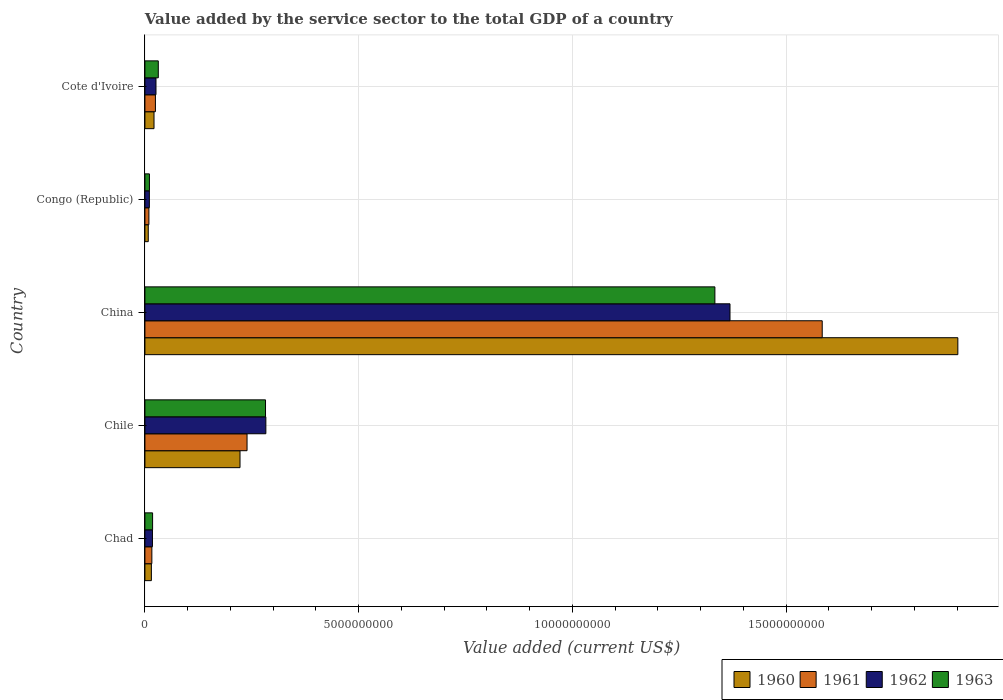How many different coloured bars are there?
Offer a very short reply. 4. What is the label of the 2nd group of bars from the top?
Your answer should be compact. Congo (Republic). In how many cases, is the number of bars for a given country not equal to the number of legend labels?
Provide a succinct answer. 0. What is the value added by the service sector to the total GDP in 1960 in Chile?
Make the answer very short. 2.22e+09. Across all countries, what is the maximum value added by the service sector to the total GDP in 1962?
Offer a very short reply. 1.37e+1. Across all countries, what is the minimum value added by the service sector to the total GDP in 1962?
Offer a terse response. 1.04e+08. In which country was the value added by the service sector to the total GDP in 1962 minimum?
Offer a terse response. Congo (Republic). What is the total value added by the service sector to the total GDP in 1962 in the graph?
Your response must be concise. 1.71e+1. What is the difference between the value added by the service sector to the total GDP in 1962 in Chad and that in China?
Keep it short and to the point. -1.35e+1. What is the difference between the value added by the service sector to the total GDP in 1961 in Chile and the value added by the service sector to the total GDP in 1962 in Congo (Republic)?
Provide a succinct answer. 2.29e+09. What is the average value added by the service sector to the total GDP in 1960 per country?
Your answer should be very brief. 4.34e+09. What is the difference between the value added by the service sector to the total GDP in 1963 and value added by the service sector to the total GDP in 1961 in Chad?
Your answer should be very brief. 1.71e+07. What is the ratio of the value added by the service sector to the total GDP in 1962 in Congo (Republic) to that in Cote d'Ivoire?
Your answer should be compact. 0.4. What is the difference between the highest and the second highest value added by the service sector to the total GDP in 1961?
Offer a terse response. 1.35e+1. What is the difference between the highest and the lowest value added by the service sector to the total GDP in 1963?
Your answer should be compact. 1.32e+1. What does the 2nd bar from the bottom in Congo (Republic) represents?
Your answer should be compact. 1961. Does the graph contain grids?
Give a very brief answer. Yes. Where does the legend appear in the graph?
Make the answer very short. Bottom right. How many legend labels are there?
Your response must be concise. 4. How are the legend labels stacked?
Offer a very short reply. Horizontal. What is the title of the graph?
Provide a short and direct response. Value added by the service sector to the total GDP of a country. What is the label or title of the X-axis?
Provide a succinct answer. Value added (current US$). What is the label or title of the Y-axis?
Give a very brief answer. Country. What is the Value added (current US$) of 1960 in Chad?
Provide a succinct answer. 1.51e+08. What is the Value added (current US$) in 1961 in Chad?
Make the answer very short. 1.62e+08. What is the Value added (current US$) of 1962 in Chad?
Ensure brevity in your answer.  1.76e+08. What is the Value added (current US$) of 1963 in Chad?
Provide a short and direct response. 1.80e+08. What is the Value added (current US$) of 1960 in Chile?
Your response must be concise. 2.22e+09. What is the Value added (current US$) in 1961 in Chile?
Provide a succinct answer. 2.39e+09. What is the Value added (current US$) of 1962 in Chile?
Give a very brief answer. 2.83e+09. What is the Value added (current US$) of 1963 in Chile?
Keep it short and to the point. 2.82e+09. What is the Value added (current US$) of 1960 in China?
Offer a terse response. 1.90e+1. What is the Value added (current US$) in 1961 in China?
Your response must be concise. 1.58e+1. What is the Value added (current US$) of 1962 in China?
Give a very brief answer. 1.37e+1. What is the Value added (current US$) of 1963 in China?
Provide a succinct answer. 1.33e+1. What is the Value added (current US$) in 1960 in Congo (Republic)?
Your answer should be compact. 7.82e+07. What is the Value added (current US$) in 1961 in Congo (Republic)?
Your answer should be very brief. 9.33e+07. What is the Value added (current US$) in 1962 in Congo (Republic)?
Make the answer very short. 1.04e+08. What is the Value added (current US$) of 1963 in Congo (Republic)?
Your answer should be very brief. 1.06e+08. What is the Value added (current US$) of 1960 in Cote d'Ivoire?
Provide a succinct answer. 2.13e+08. What is the Value added (current US$) of 1961 in Cote d'Ivoire?
Give a very brief answer. 2.46e+08. What is the Value added (current US$) of 1962 in Cote d'Ivoire?
Offer a very short reply. 2.59e+08. What is the Value added (current US$) in 1963 in Cote d'Ivoire?
Offer a very short reply. 3.13e+08. Across all countries, what is the maximum Value added (current US$) of 1960?
Keep it short and to the point. 1.90e+1. Across all countries, what is the maximum Value added (current US$) in 1961?
Give a very brief answer. 1.58e+1. Across all countries, what is the maximum Value added (current US$) of 1962?
Your answer should be compact. 1.37e+1. Across all countries, what is the maximum Value added (current US$) in 1963?
Keep it short and to the point. 1.33e+1. Across all countries, what is the minimum Value added (current US$) in 1960?
Your answer should be very brief. 7.82e+07. Across all countries, what is the minimum Value added (current US$) in 1961?
Your answer should be compact. 9.33e+07. Across all countries, what is the minimum Value added (current US$) in 1962?
Your answer should be compact. 1.04e+08. Across all countries, what is the minimum Value added (current US$) of 1963?
Ensure brevity in your answer.  1.06e+08. What is the total Value added (current US$) in 1960 in the graph?
Provide a succinct answer. 2.17e+1. What is the total Value added (current US$) of 1961 in the graph?
Your answer should be compact. 1.87e+1. What is the total Value added (current US$) in 1962 in the graph?
Your answer should be compact. 1.71e+1. What is the total Value added (current US$) in 1963 in the graph?
Offer a very short reply. 1.68e+1. What is the difference between the Value added (current US$) in 1960 in Chad and that in Chile?
Offer a terse response. -2.07e+09. What is the difference between the Value added (current US$) in 1961 in Chad and that in Chile?
Give a very brief answer. -2.23e+09. What is the difference between the Value added (current US$) in 1962 in Chad and that in Chile?
Ensure brevity in your answer.  -2.65e+09. What is the difference between the Value added (current US$) of 1963 in Chad and that in Chile?
Your response must be concise. -2.64e+09. What is the difference between the Value added (current US$) in 1960 in Chad and that in China?
Ensure brevity in your answer.  -1.89e+1. What is the difference between the Value added (current US$) in 1961 in Chad and that in China?
Offer a very short reply. -1.57e+1. What is the difference between the Value added (current US$) of 1962 in Chad and that in China?
Offer a terse response. -1.35e+1. What is the difference between the Value added (current US$) in 1963 in Chad and that in China?
Provide a short and direct response. -1.32e+1. What is the difference between the Value added (current US$) in 1960 in Chad and that in Congo (Republic)?
Offer a terse response. 7.27e+07. What is the difference between the Value added (current US$) in 1961 in Chad and that in Congo (Republic)?
Offer a terse response. 6.92e+07. What is the difference between the Value added (current US$) in 1962 in Chad and that in Congo (Republic)?
Ensure brevity in your answer.  7.25e+07. What is the difference between the Value added (current US$) in 1963 in Chad and that in Congo (Republic)?
Your response must be concise. 7.41e+07. What is the difference between the Value added (current US$) in 1960 in Chad and that in Cote d'Ivoire?
Give a very brief answer. -6.18e+07. What is the difference between the Value added (current US$) of 1961 in Chad and that in Cote d'Ivoire?
Your answer should be very brief. -8.31e+07. What is the difference between the Value added (current US$) of 1962 in Chad and that in Cote d'Ivoire?
Your response must be concise. -8.26e+07. What is the difference between the Value added (current US$) of 1963 in Chad and that in Cote d'Ivoire?
Keep it short and to the point. -1.33e+08. What is the difference between the Value added (current US$) in 1960 in Chile and that in China?
Offer a very short reply. -1.68e+1. What is the difference between the Value added (current US$) of 1961 in Chile and that in China?
Provide a succinct answer. -1.35e+1. What is the difference between the Value added (current US$) of 1962 in Chile and that in China?
Make the answer very short. -1.09e+1. What is the difference between the Value added (current US$) of 1963 in Chile and that in China?
Offer a very short reply. -1.05e+1. What is the difference between the Value added (current US$) in 1960 in Chile and that in Congo (Republic)?
Keep it short and to the point. 2.15e+09. What is the difference between the Value added (current US$) of 1961 in Chile and that in Congo (Republic)?
Your answer should be very brief. 2.30e+09. What is the difference between the Value added (current US$) in 1962 in Chile and that in Congo (Republic)?
Keep it short and to the point. 2.73e+09. What is the difference between the Value added (current US$) in 1963 in Chile and that in Congo (Republic)?
Your answer should be very brief. 2.72e+09. What is the difference between the Value added (current US$) in 1960 in Chile and that in Cote d'Ivoire?
Your answer should be very brief. 2.01e+09. What is the difference between the Value added (current US$) in 1961 in Chile and that in Cote d'Ivoire?
Your answer should be compact. 2.14e+09. What is the difference between the Value added (current US$) of 1962 in Chile and that in Cote d'Ivoire?
Keep it short and to the point. 2.57e+09. What is the difference between the Value added (current US$) of 1963 in Chile and that in Cote d'Ivoire?
Keep it short and to the point. 2.51e+09. What is the difference between the Value added (current US$) in 1960 in China and that in Congo (Republic)?
Give a very brief answer. 1.89e+1. What is the difference between the Value added (current US$) in 1961 in China and that in Congo (Republic)?
Make the answer very short. 1.57e+1. What is the difference between the Value added (current US$) in 1962 in China and that in Congo (Republic)?
Offer a terse response. 1.36e+1. What is the difference between the Value added (current US$) of 1963 in China and that in Congo (Republic)?
Offer a very short reply. 1.32e+1. What is the difference between the Value added (current US$) of 1960 in China and that in Cote d'Ivoire?
Your answer should be compact. 1.88e+1. What is the difference between the Value added (current US$) in 1961 in China and that in Cote d'Ivoire?
Your answer should be very brief. 1.56e+1. What is the difference between the Value added (current US$) of 1962 in China and that in Cote d'Ivoire?
Your answer should be compact. 1.34e+1. What is the difference between the Value added (current US$) of 1963 in China and that in Cote d'Ivoire?
Keep it short and to the point. 1.30e+1. What is the difference between the Value added (current US$) in 1960 in Congo (Republic) and that in Cote d'Ivoire?
Offer a terse response. -1.35e+08. What is the difference between the Value added (current US$) of 1961 in Congo (Republic) and that in Cote d'Ivoire?
Your answer should be compact. -1.52e+08. What is the difference between the Value added (current US$) of 1962 in Congo (Republic) and that in Cote d'Ivoire?
Give a very brief answer. -1.55e+08. What is the difference between the Value added (current US$) of 1963 in Congo (Republic) and that in Cote d'Ivoire?
Your answer should be very brief. -2.08e+08. What is the difference between the Value added (current US$) of 1960 in Chad and the Value added (current US$) of 1961 in Chile?
Offer a terse response. -2.24e+09. What is the difference between the Value added (current US$) of 1960 in Chad and the Value added (current US$) of 1962 in Chile?
Offer a terse response. -2.68e+09. What is the difference between the Value added (current US$) of 1960 in Chad and the Value added (current US$) of 1963 in Chile?
Provide a short and direct response. -2.67e+09. What is the difference between the Value added (current US$) in 1961 in Chad and the Value added (current US$) in 1962 in Chile?
Your answer should be compact. -2.67e+09. What is the difference between the Value added (current US$) in 1961 in Chad and the Value added (current US$) in 1963 in Chile?
Offer a very short reply. -2.66e+09. What is the difference between the Value added (current US$) in 1962 in Chad and the Value added (current US$) in 1963 in Chile?
Keep it short and to the point. -2.64e+09. What is the difference between the Value added (current US$) of 1960 in Chad and the Value added (current US$) of 1961 in China?
Provide a short and direct response. -1.57e+1. What is the difference between the Value added (current US$) of 1960 in Chad and the Value added (current US$) of 1962 in China?
Offer a terse response. -1.35e+1. What is the difference between the Value added (current US$) in 1960 in Chad and the Value added (current US$) in 1963 in China?
Provide a short and direct response. -1.32e+1. What is the difference between the Value added (current US$) in 1961 in Chad and the Value added (current US$) in 1962 in China?
Ensure brevity in your answer.  -1.35e+1. What is the difference between the Value added (current US$) in 1961 in Chad and the Value added (current US$) in 1963 in China?
Your answer should be compact. -1.32e+1. What is the difference between the Value added (current US$) in 1962 in Chad and the Value added (current US$) in 1963 in China?
Provide a short and direct response. -1.32e+1. What is the difference between the Value added (current US$) in 1960 in Chad and the Value added (current US$) in 1961 in Congo (Republic)?
Your answer should be very brief. 5.77e+07. What is the difference between the Value added (current US$) in 1960 in Chad and the Value added (current US$) in 1962 in Congo (Republic)?
Offer a terse response. 4.72e+07. What is the difference between the Value added (current US$) in 1960 in Chad and the Value added (current US$) in 1963 in Congo (Republic)?
Your response must be concise. 4.54e+07. What is the difference between the Value added (current US$) in 1961 in Chad and the Value added (current US$) in 1962 in Congo (Republic)?
Give a very brief answer. 5.87e+07. What is the difference between the Value added (current US$) of 1961 in Chad and the Value added (current US$) of 1963 in Congo (Republic)?
Your response must be concise. 5.69e+07. What is the difference between the Value added (current US$) of 1962 in Chad and the Value added (current US$) of 1963 in Congo (Republic)?
Offer a very short reply. 7.08e+07. What is the difference between the Value added (current US$) of 1960 in Chad and the Value added (current US$) of 1961 in Cote d'Ivoire?
Keep it short and to the point. -9.46e+07. What is the difference between the Value added (current US$) of 1960 in Chad and the Value added (current US$) of 1962 in Cote d'Ivoire?
Keep it short and to the point. -1.08e+08. What is the difference between the Value added (current US$) of 1960 in Chad and the Value added (current US$) of 1963 in Cote d'Ivoire?
Provide a succinct answer. -1.62e+08. What is the difference between the Value added (current US$) in 1961 in Chad and the Value added (current US$) in 1962 in Cote d'Ivoire?
Offer a terse response. -9.64e+07. What is the difference between the Value added (current US$) of 1961 in Chad and the Value added (current US$) of 1963 in Cote d'Ivoire?
Ensure brevity in your answer.  -1.51e+08. What is the difference between the Value added (current US$) of 1962 in Chad and the Value added (current US$) of 1963 in Cote d'Ivoire?
Your answer should be compact. -1.37e+08. What is the difference between the Value added (current US$) of 1960 in Chile and the Value added (current US$) of 1961 in China?
Make the answer very short. -1.36e+1. What is the difference between the Value added (current US$) in 1960 in Chile and the Value added (current US$) in 1962 in China?
Offer a very short reply. -1.15e+1. What is the difference between the Value added (current US$) of 1960 in Chile and the Value added (current US$) of 1963 in China?
Your response must be concise. -1.11e+1. What is the difference between the Value added (current US$) in 1961 in Chile and the Value added (current US$) in 1962 in China?
Your response must be concise. -1.13e+1. What is the difference between the Value added (current US$) in 1961 in Chile and the Value added (current US$) in 1963 in China?
Offer a very short reply. -1.09e+1. What is the difference between the Value added (current US$) in 1962 in Chile and the Value added (current US$) in 1963 in China?
Offer a very short reply. -1.05e+1. What is the difference between the Value added (current US$) in 1960 in Chile and the Value added (current US$) in 1961 in Congo (Republic)?
Your answer should be compact. 2.13e+09. What is the difference between the Value added (current US$) in 1960 in Chile and the Value added (current US$) in 1962 in Congo (Republic)?
Offer a terse response. 2.12e+09. What is the difference between the Value added (current US$) of 1960 in Chile and the Value added (current US$) of 1963 in Congo (Republic)?
Ensure brevity in your answer.  2.12e+09. What is the difference between the Value added (current US$) in 1961 in Chile and the Value added (current US$) in 1962 in Congo (Republic)?
Offer a very short reply. 2.29e+09. What is the difference between the Value added (current US$) of 1961 in Chile and the Value added (current US$) of 1963 in Congo (Republic)?
Your answer should be very brief. 2.28e+09. What is the difference between the Value added (current US$) in 1962 in Chile and the Value added (current US$) in 1963 in Congo (Republic)?
Your response must be concise. 2.72e+09. What is the difference between the Value added (current US$) of 1960 in Chile and the Value added (current US$) of 1961 in Cote d'Ivoire?
Keep it short and to the point. 1.98e+09. What is the difference between the Value added (current US$) of 1960 in Chile and the Value added (current US$) of 1962 in Cote d'Ivoire?
Give a very brief answer. 1.97e+09. What is the difference between the Value added (current US$) of 1960 in Chile and the Value added (current US$) of 1963 in Cote d'Ivoire?
Offer a very short reply. 1.91e+09. What is the difference between the Value added (current US$) in 1961 in Chile and the Value added (current US$) in 1962 in Cote d'Ivoire?
Your answer should be very brief. 2.13e+09. What is the difference between the Value added (current US$) of 1961 in Chile and the Value added (current US$) of 1963 in Cote d'Ivoire?
Provide a succinct answer. 2.08e+09. What is the difference between the Value added (current US$) of 1962 in Chile and the Value added (current US$) of 1963 in Cote d'Ivoire?
Offer a very short reply. 2.52e+09. What is the difference between the Value added (current US$) of 1960 in China and the Value added (current US$) of 1961 in Congo (Republic)?
Provide a succinct answer. 1.89e+1. What is the difference between the Value added (current US$) of 1960 in China and the Value added (current US$) of 1962 in Congo (Republic)?
Offer a terse response. 1.89e+1. What is the difference between the Value added (current US$) in 1960 in China and the Value added (current US$) in 1963 in Congo (Republic)?
Provide a short and direct response. 1.89e+1. What is the difference between the Value added (current US$) in 1961 in China and the Value added (current US$) in 1962 in Congo (Republic)?
Offer a terse response. 1.57e+1. What is the difference between the Value added (current US$) of 1961 in China and the Value added (current US$) of 1963 in Congo (Republic)?
Provide a succinct answer. 1.57e+1. What is the difference between the Value added (current US$) of 1962 in China and the Value added (current US$) of 1963 in Congo (Republic)?
Provide a succinct answer. 1.36e+1. What is the difference between the Value added (current US$) in 1960 in China and the Value added (current US$) in 1961 in Cote d'Ivoire?
Offer a terse response. 1.88e+1. What is the difference between the Value added (current US$) of 1960 in China and the Value added (current US$) of 1962 in Cote d'Ivoire?
Your answer should be compact. 1.88e+1. What is the difference between the Value added (current US$) in 1960 in China and the Value added (current US$) in 1963 in Cote d'Ivoire?
Offer a terse response. 1.87e+1. What is the difference between the Value added (current US$) of 1961 in China and the Value added (current US$) of 1962 in Cote d'Ivoire?
Offer a terse response. 1.56e+1. What is the difference between the Value added (current US$) in 1961 in China and the Value added (current US$) in 1963 in Cote d'Ivoire?
Your answer should be compact. 1.55e+1. What is the difference between the Value added (current US$) of 1962 in China and the Value added (current US$) of 1963 in Cote d'Ivoire?
Offer a very short reply. 1.34e+1. What is the difference between the Value added (current US$) in 1960 in Congo (Republic) and the Value added (current US$) in 1961 in Cote d'Ivoire?
Keep it short and to the point. -1.67e+08. What is the difference between the Value added (current US$) of 1960 in Congo (Republic) and the Value added (current US$) of 1962 in Cote d'Ivoire?
Provide a short and direct response. -1.81e+08. What is the difference between the Value added (current US$) in 1960 in Congo (Republic) and the Value added (current US$) in 1963 in Cote d'Ivoire?
Keep it short and to the point. -2.35e+08. What is the difference between the Value added (current US$) of 1961 in Congo (Republic) and the Value added (current US$) of 1962 in Cote d'Ivoire?
Your answer should be compact. -1.66e+08. What is the difference between the Value added (current US$) of 1961 in Congo (Republic) and the Value added (current US$) of 1963 in Cote d'Ivoire?
Your answer should be compact. -2.20e+08. What is the difference between the Value added (current US$) in 1962 in Congo (Republic) and the Value added (current US$) in 1963 in Cote d'Ivoire?
Keep it short and to the point. -2.09e+08. What is the average Value added (current US$) in 1960 per country?
Provide a succinct answer. 4.34e+09. What is the average Value added (current US$) in 1961 per country?
Provide a short and direct response. 3.75e+09. What is the average Value added (current US$) of 1962 per country?
Ensure brevity in your answer.  3.41e+09. What is the average Value added (current US$) in 1963 per country?
Give a very brief answer. 3.35e+09. What is the difference between the Value added (current US$) in 1960 and Value added (current US$) in 1961 in Chad?
Provide a short and direct response. -1.15e+07. What is the difference between the Value added (current US$) of 1960 and Value added (current US$) of 1962 in Chad?
Your answer should be compact. -2.53e+07. What is the difference between the Value added (current US$) in 1960 and Value added (current US$) in 1963 in Chad?
Offer a very short reply. -2.87e+07. What is the difference between the Value added (current US$) in 1961 and Value added (current US$) in 1962 in Chad?
Ensure brevity in your answer.  -1.38e+07. What is the difference between the Value added (current US$) of 1961 and Value added (current US$) of 1963 in Chad?
Your response must be concise. -1.71e+07. What is the difference between the Value added (current US$) of 1962 and Value added (current US$) of 1963 in Chad?
Offer a very short reply. -3.34e+06. What is the difference between the Value added (current US$) of 1960 and Value added (current US$) of 1961 in Chile?
Give a very brief answer. -1.64e+08. What is the difference between the Value added (current US$) in 1960 and Value added (current US$) in 1962 in Chile?
Your response must be concise. -6.04e+08. What is the difference between the Value added (current US$) of 1960 and Value added (current US$) of 1963 in Chile?
Your answer should be compact. -5.96e+08. What is the difference between the Value added (current US$) of 1961 and Value added (current US$) of 1962 in Chile?
Offer a terse response. -4.40e+08. What is the difference between the Value added (current US$) of 1961 and Value added (current US$) of 1963 in Chile?
Offer a very short reply. -4.32e+08. What is the difference between the Value added (current US$) of 1962 and Value added (current US$) of 1963 in Chile?
Your answer should be very brief. 8.01e+06. What is the difference between the Value added (current US$) in 1960 and Value added (current US$) in 1961 in China?
Provide a short and direct response. 3.17e+09. What is the difference between the Value added (current US$) of 1960 and Value added (current US$) of 1962 in China?
Provide a short and direct response. 5.33e+09. What is the difference between the Value added (current US$) in 1960 and Value added (current US$) in 1963 in China?
Offer a terse response. 5.68e+09. What is the difference between the Value added (current US$) in 1961 and Value added (current US$) in 1962 in China?
Your answer should be compact. 2.16e+09. What is the difference between the Value added (current US$) of 1961 and Value added (current US$) of 1963 in China?
Provide a succinct answer. 2.51e+09. What is the difference between the Value added (current US$) in 1962 and Value added (current US$) in 1963 in China?
Offer a terse response. 3.53e+08. What is the difference between the Value added (current US$) of 1960 and Value added (current US$) of 1961 in Congo (Republic)?
Make the answer very short. -1.51e+07. What is the difference between the Value added (current US$) in 1960 and Value added (current US$) in 1962 in Congo (Republic)?
Your answer should be very brief. -2.55e+07. What is the difference between the Value added (current US$) of 1960 and Value added (current US$) of 1963 in Congo (Republic)?
Provide a short and direct response. -2.73e+07. What is the difference between the Value added (current US$) of 1961 and Value added (current US$) of 1962 in Congo (Republic)?
Provide a short and direct response. -1.05e+07. What is the difference between the Value added (current US$) of 1961 and Value added (current US$) of 1963 in Congo (Republic)?
Give a very brief answer. -1.23e+07. What is the difference between the Value added (current US$) in 1962 and Value added (current US$) in 1963 in Congo (Republic)?
Provide a short and direct response. -1.79e+06. What is the difference between the Value added (current US$) in 1960 and Value added (current US$) in 1961 in Cote d'Ivoire?
Keep it short and to the point. -3.28e+07. What is the difference between the Value added (current US$) of 1960 and Value added (current US$) of 1962 in Cote d'Ivoire?
Provide a short and direct response. -4.61e+07. What is the difference between the Value added (current US$) in 1960 and Value added (current US$) in 1963 in Cote d'Ivoire?
Offer a very short reply. -1.00e+08. What is the difference between the Value added (current US$) of 1961 and Value added (current US$) of 1962 in Cote d'Ivoire?
Make the answer very short. -1.33e+07. What is the difference between the Value added (current US$) in 1961 and Value added (current US$) in 1963 in Cote d'Ivoire?
Keep it short and to the point. -6.75e+07. What is the difference between the Value added (current US$) in 1962 and Value added (current US$) in 1963 in Cote d'Ivoire?
Keep it short and to the point. -5.42e+07. What is the ratio of the Value added (current US$) in 1960 in Chad to that in Chile?
Your answer should be very brief. 0.07. What is the ratio of the Value added (current US$) in 1961 in Chad to that in Chile?
Offer a terse response. 0.07. What is the ratio of the Value added (current US$) in 1962 in Chad to that in Chile?
Provide a short and direct response. 0.06. What is the ratio of the Value added (current US$) in 1963 in Chad to that in Chile?
Your response must be concise. 0.06. What is the ratio of the Value added (current US$) of 1960 in Chad to that in China?
Offer a terse response. 0.01. What is the ratio of the Value added (current US$) in 1961 in Chad to that in China?
Offer a very short reply. 0.01. What is the ratio of the Value added (current US$) of 1962 in Chad to that in China?
Your answer should be very brief. 0.01. What is the ratio of the Value added (current US$) of 1963 in Chad to that in China?
Your response must be concise. 0.01. What is the ratio of the Value added (current US$) in 1960 in Chad to that in Congo (Republic)?
Your answer should be very brief. 1.93. What is the ratio of the Value added (current US$) in 1961 in Chad to that in Congo (Republic)?
Provide a succinct answer. 1.74. What is the ratio of the Value added (current US$) in 1962 in Chad to that in Congo (Republic)?
Provide a succinct answer. 1.7. What is the ratio of the Value added (current US$) of 1963 in Chad to that in Congo (Republic)?
Keep it short and to the point. 1.7. What is the ratio of the Value added (current US$) in 1960 in Chad to that in Cote d'Ivoire?
Provide a succinct answer. 0.71. What is the ratio of the Value added (current US$) in 1961 in Chad to that in Cote d'Ivoire?
Provide a short and direct response. 0.66. What is the ratio of the Value added (current US$) of 1962 in Chad to that in Cote d'Ivoire?
Keep it short and to the point. 0.68. What is the ratio of the Value added (current US$) in 1963 in Chad to that in Cote d'Ivoire?
Give a very brief answer. 0.57. What is the ratio of the Value added (current US$) in 1960 in Chile to that in China?
Ensure brevity in your answer.  0.12. What is the ratio of the Value added (current US$) of 1961 in Chile to that in China?
Offer a terse response. 0.15. What is the ratio of the Value added (current US$) of 1962 in Chile to that in China?
Ensure brevity in your answer.  0.21. What is the ratio of the Value added (current US$) of 1963 in Chile to that in China?
Offer a terse response. 0.21. What is the ratio of the Value added (current US$) in 1960 in Chile to that in Congo (Republic)?
Offer a very short reply. 28.44. What is the ratio of the Value added (current US$) of 1961 in Chile to that in Congo (Republic)?
Provide a short and direct response. 25.61. What is the ratio of the Value added (current US$) in 1962 in Chile to that in Congo (Republic)?
Provide a succinct answer. 27.27. What is the ratio of the Value added (current US$) in 1963 in Chile to that in Congo (Republic)?
Your response must be concise. 26.73. What is the ratio of the Value added (current US$) in 1960 in Chile to that in Cote d'Ivoire?
Offer a terse response. 10.45. What is the ratio of the Value added (current US$) in 1961 in Chile to that in Cote d'Ivoire?
Your response must be concise. 9.73. What is the ratio of the Value added (current US$) of 1962 in Chile to that in Cote d'Ivoire?
Offer a terse response. 10.93. What is the ratio of the Value added (current US$) in 1963 in Chile to that in Cote d'Ivoire?
Provide a succinct answer. 9.01. What is the ratio of the Value added (current US$) in 1960 in China to that in Congo (Republic)?
Provide a succinct answer. 243.12. What is the ratio of the Value added (current US$) of 1961 in China to that in Congo (Republic)?
Offer a very short reply. 169.84. What is the ratio of the Value added (current US$) of 1962 in China to that in Congo (Republic)?
Provide a short and direct response. 131.91. What is the ratio of the Value added (current US$) of 1963 in China to that in Congo (Republic)?
Provide a succinct answer. 126.33. What is the ratio of the Value added (current US$) in 1960 in China to that in Cote d'Ivoire?
Make the answer very short. 89.37. What is the ratio of the Value added (current US$) of 1961 in China to that in Cote d'Ivoire?
Your answer should be very brief. 64.52. What is the ratio of the Value added (current US$) in 1962 in China to that in Cote d'Ivoire?
Offer a very short reply. 52.87. What is the ratio of the Value added (current US$) in 1963 in China to that in Cote d'Ivoire?
Provide a succinct answer. 42.59. What is the ratio of the Value added (current US$) in 1960 in Congo (Republic) to that in Cote d'Ivoire?
Keep it short and to the point. 0.37. What is the ratio of the Value added (current US$) in 1961 in Congo (Republic) to that in Cote d'Ivoire?
Keep it short and to the point. 0.38. What is the ratio of the Value added (current US$) in 1962 in Congo (Republic) to that in Cote d'Ivoire?
Give a very brief answer. 0.4. What is the ratio of the Value added (current US$) in 1963 in Congo (Republic) to that in Cote d'Ivoire?
Your response must be concise. 0.34. What is the difference between the highest and the second highest Value added (current US$) of 1960?
Your answer should be very brief. 1.68e+1. What is the difference between the highest and the second highest Value added (current US$) in 1961?
Offer a very short reply. 1.35e+1. What is the difference between the highest and the second highest Value added (current US$) in 1962?
Give a very brief answer. 1.09e+1. What is the difference between the highest and the second highest Value added (current US$) of 1963?
Make the answer very short. 1.05e+1. What is the difference between the highest and the lowest Value added (current US$) in 1960?
Your answer should be very brief. 1.89e+1. What is the difference between the highest and the lowest Value added (current US$) in 1961?
Offer a very short reply. 1.57e+1. What is the difference between the highest and the lowest Value added (current US$) in 1962?
Your answer should be very brief. 1.36e+1. What is the difference between the highest and the lowest Value added (current US$) of 1963?
Keep it short and to the point. 1.32e+1. 